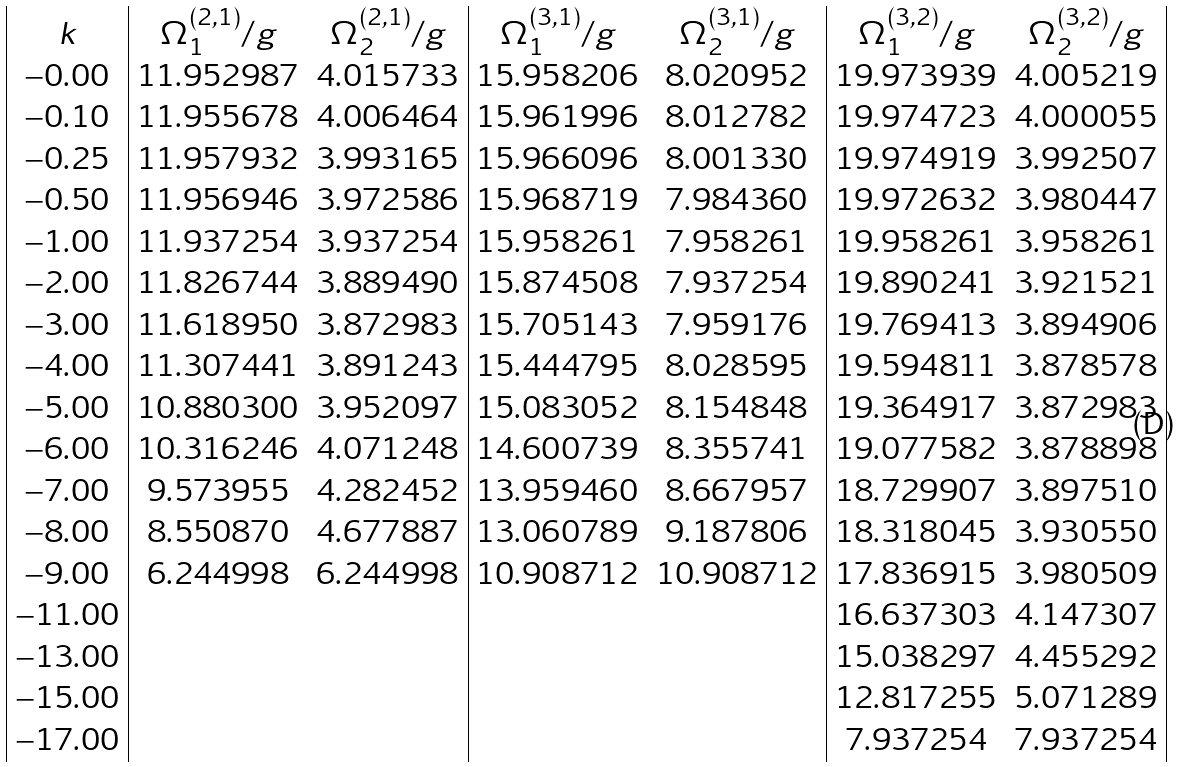Convert formula to latex. <formula><loc_0><loc_0><loc_500><loc_500>\begin{array} { | c | c c | c c | c c | } k & \Omega ^ { ( 2 , 1 ) } _ { 1 } / g & \Omega ^ { ( 2 , 1 ) } _ { 2 } / g & \Omega ^ { ( 3 , 1 ) } _ { 1 } / g & \Omega ^ { ( 3 , 1 ) } _ { 2 } / g & \Omega ^ { ( 3 , 2 ) } _ { 1 } / g & \Omega ^ { ( 3 , 2 ) } _ { 2 } / g \\ - 0 . 0 0 & 1 1 . 9 5 2 9 8 7 & 4 . 0 1 5 7 3 3 & 1 5 . 9 5 8 2 0 6 & 8 . 0 2 0 9 5 2 & 1 9 . 9 7 3 9 3 9 & 4 . 0 0 5 2 1 9 \\ - 0 . 1 0 & 1 1 . 9 5 5 6 7 8 & 4 . 0 0 6 4 6 4 & 1 5 . 9 6 1 9 9 6 & 8 . 0 1 2 7 8 2 & 1 9 . 9 7 4 7 2 3 & 4 . 0 0 0 0 5 5 \\ - 0 . 2 5 & 1 1 . 9 5 7 9 3 2 & 3 . 9 9 3 1 6 5 & 1 5 . 9 6 6 0 9 6 & 8 . 0 0 1 3 3 0 & 1 9 . 9 7 4 9 1 9 & 3 . 9 9 2 5 0 7 \\ - 0 . 5 0 & 1 1 . 9 5 6 9 4 6 & 3 . 9 7 2 5 8 6 & 1 5 . 9 6 8 7 1 9 & 7 . 9 8 4 3 6 0 & 1 9 . 9 7 2 6 3 2 & 3 . 9 8 0 4 4 7 \\ - 1 . 0 0 & 1 1 . 9 3 7 2 5 4 & 3 . 9 3 7 2 5 4 & 1 5 . 9 5 8 2 6 1 & 7 . 9 5 8 2 6 1 & 1 9 . 9 5 8 2 6 1 & 3 . 9 5 8 2 6 1 \\ - 2 . 0 0 & 1 1 . 8 2 6 7 4 4 & 3 . 8 8 9 4 9 0 & 1 5 . 8 7 4 5 0 8 & 7 . 9 3 7 2 5 4 & 1 9 . 8 9 0 2 4 1 & 3 . 9 2 1 5 2 1 \\ - 3 . 0 0 & 1 1 . 6 1 8 9 5 0 & 3 . 8 7 2 9 8 3 & 1 5 . 7 0 5 1 4 3 & 7 . 9 5 9 1 7 6 & 1 9 . 7 6 9 4 1 3 & 3 . 8 9 4 9 0 6 \\ - 4 . 0 0 & 1 1 . 3 0 7 4 4 1 & 3 . 8 9 1 2 4 3 & 1 5 . 4 4 4 7 9 5 & 8 . 0 2 8 5 9 5 & 1 9 . 5 9 4 8 1 1 & 3 . 8 7 8 5 7 8 \\ - 5 . 0 0 & 1 0 . 8 8 0 3 0 0 & 3 . 9 5 2 0 9 7 & 1 5 . 0 8 3 0 5 2 & 8 . 1 5 4 8 4 8 & 1 9 . 3 6 4 9 1 7 & 3 . 8 7 2 9 8 3 \\ - 6 . 0 0 & 1 0 . 3 1 6 2 4 6 & 4 . 0 7 1 2 4 8 & 1 4 . 6 0 0 7 3 9 & 8 . 3 5 5 7 4 1 & 1 9 . 0 7 7 5 8 2 & 3 . 8 7 8 8 9 8 \\ - 7 . 0 0 & 9 . 5 7 3 9 5 5 & 4 . 2 8 2 4 5 2 & 1 3 . 9 5 9 4 6 0 & 8 . 6 6 7 9 5 7 & 1 8 . 7 2 9 9 0 7 & 3 . 8 9 7 5 1 0 \\ - 8 . 0 0 & 8 . 5 5 0 8 7 0 & 4 . 6 7 7 8 8 7 & 1 3 . 0 6 0 7 8 9 & 9 . 1 8 7 8 0 6 & 1 8 . 3 1 8 0 4 5 & 3 . 9 3 0 5 5 0 \\ - 9 . 0 0 & 6 . 2 4 4 9 9 8 & 6 . 2 4 4 9 9 8 & 1 0 . 9 0 8 7 1 2 & 1 0 . 9 0 8 7 1 2 & 1 7 . 8 3 6 9 1 5 & 3 . 9 8 0 5 0 9 \\ - 1 1 . 0 0 & & & & & 1 6 . 6 3 7 3 0 3 & 4 . 1 4 7 3 0 7 \\ - 1 3 . 0 0 & & & & & 1 5 . 0 3 8 2 9 7 & 4 . 4 5 5 2 9 2 \\ - 1 5 . 0 0 & & & & & 1 2 . 8 1 7 2 5 5 & 5 . 0 7 1 2 8 9 \\ - 1 7 . 0 0 & & & & & 7 . 9 3 7 2 5 4 & 7 . 9 3 7 2 5 4 \\ \end{array}</formula> 